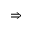Convert formula to latex. <formula><loc_0><loc_0><loc_500><loc_500>\Rightarrow</formula> 